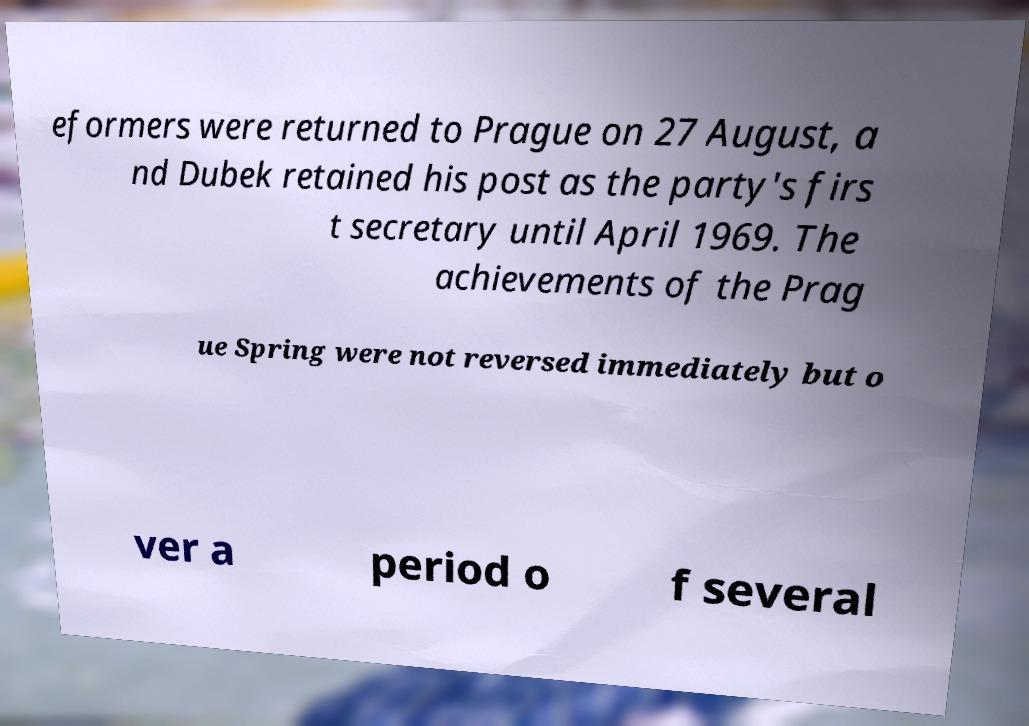Please identify and transcribe the text found in this image. eformers were returned to Prague on 27 August, a nd Dubek retained his post as the party's firs t secretary until April 1969. The achievements of the Prag ue Spring were not reversed immediately but o ver a period o f several 